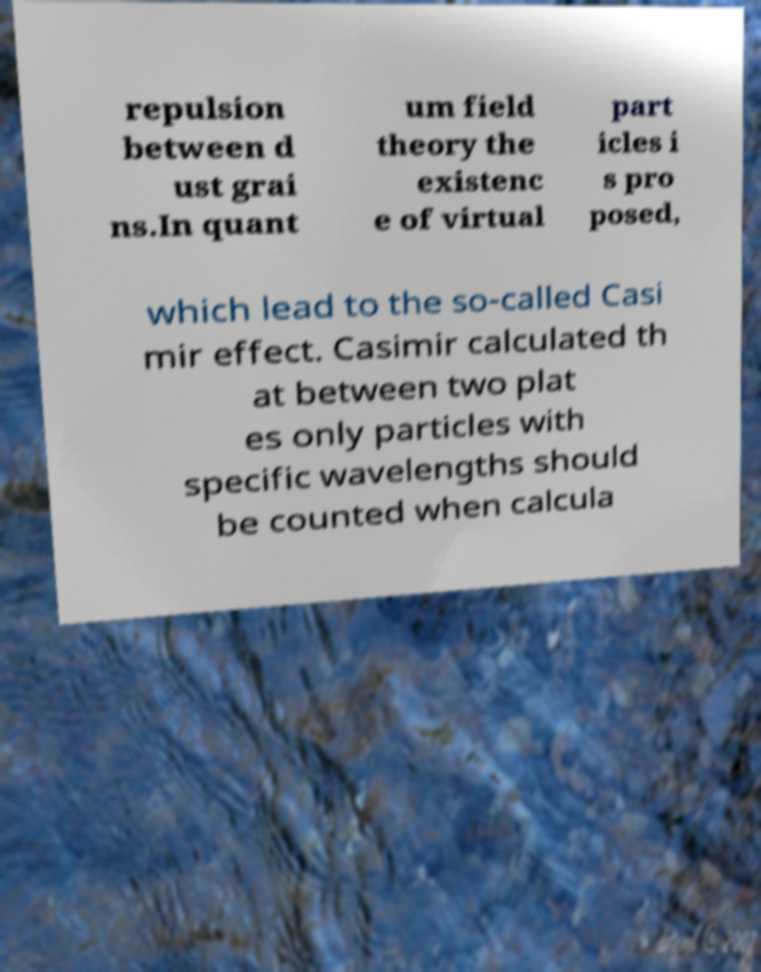Could you extract and type out the text from this image? repulsion between d ust grai ns.In quant um field theory the existenc e of virtual part icles i s pro posed, which lead to the so-called Casi mir effect. Casimir calculated th at between two plat es only particles with specific wavelengths should be counted when calcula 